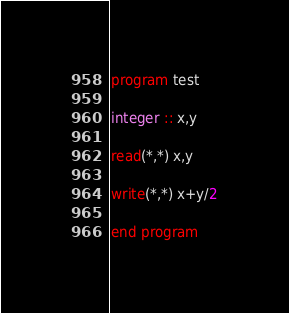<code> <loc_0><loc_0><loc_500><loc_500><_FORTRAN_>program test

integer :: x,y

read(*,*) x,y

write(*,*) x+y/2

end program
</code> 